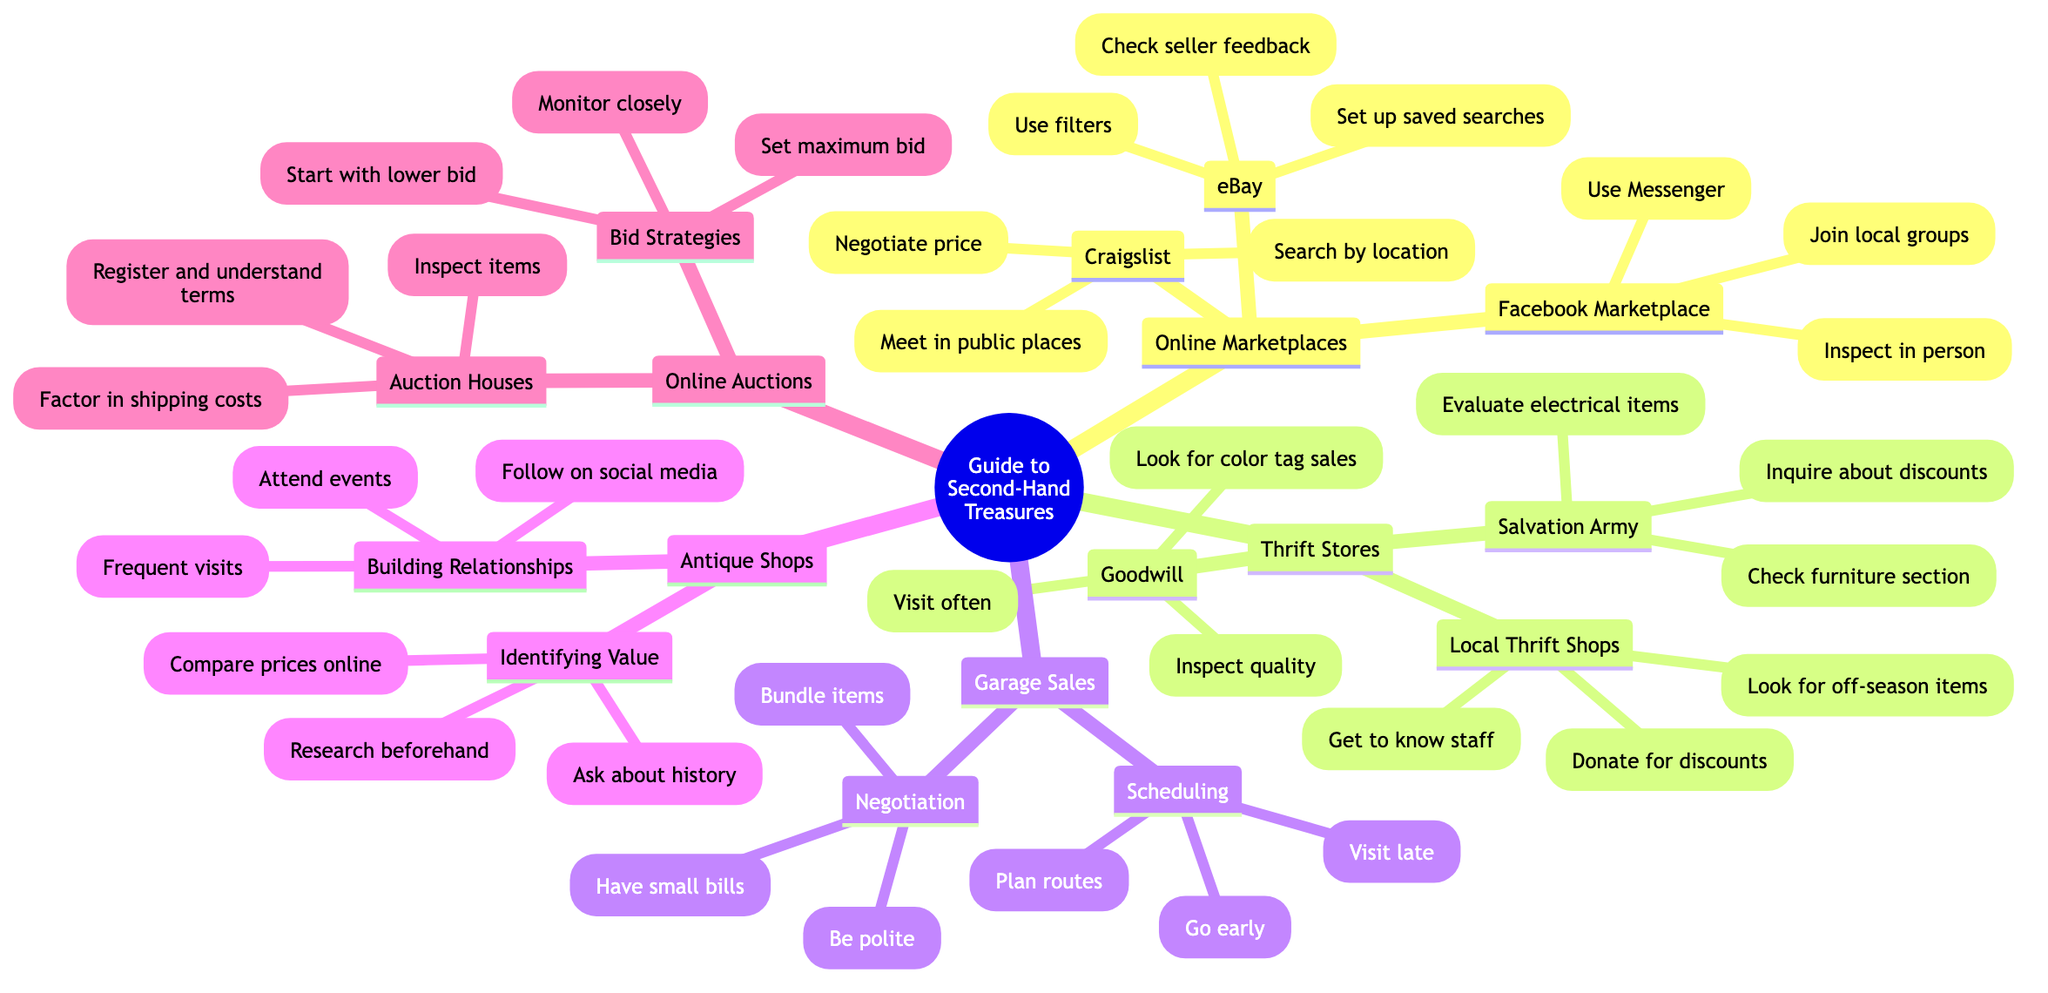What are three online marketplaces listed? The diagram shows three online marketplaces: eBay, Craigslist, and Facebook Marketplace. This information can be directly found under the "Online Marketplaces" node, which lists all included platforms.
Answer: eBay, Craigslist, Facebook Marketplace How many tips are provided for Goodwill? To find the number of tips for Goodwill, I look under the "Thrift Stores" section, specifically the "Goodwill" node, which includes three tips: "Visit often for new stock", "Look for color tag sales", and "Inspect for quality issues". This indicates there are three tips.
Answer: 3 What is one negotiation tip mentioned for garage sales? Under the "Garage Sales" section, the "Negotiation" node presents several tips, one of which is "Be polite and friendly". This requires me to refer to the specific node that details negotiation strategies.
Answer: Be polite and friendly What should you do to find local deals on Craigslist? The "Craigslist" node suggests "Search by location for local deals" as a specific tip. This is obtained by referring directly to the tips under the Craigslist section of the diagram.
Answer: Search by location for local deals How can you identify hidden gems in a thrift store? The diagram suggests asking the staff for insider tips, which can be found under the "Local Thrift Shops" section. This relates to building relationships and leveraging staff knowledge to discover valuable items.
Answer: Get to know the staff for insider tips What is a bid strategy mentioned under Online Auctions? The "Bid Strategies" node under "Online Auctions" lists several strategies, one of which is "Set a maximum bid in advance". This is noted directly in the auction strategies section, making it accessible.
Answer: Set a maximum bid in advance How many antique shops tips are related to building relationships? Referring to the "Antique Shops" section, under "Building Relationships", there are three listed tips: "Frequent visits to become a regular", "Attend store events and sales", and "Follow shops on social media". Counting these gives three tips.
Answer: 3 What is a cost factor to consider when using auction houses? The diagram specifically states "Factor in shipping and handling costs" as a tip under the "Auction Houses" node, directly highlighting an important consideration when purchasing items.
Answer: Factor in shipping and handling costs 